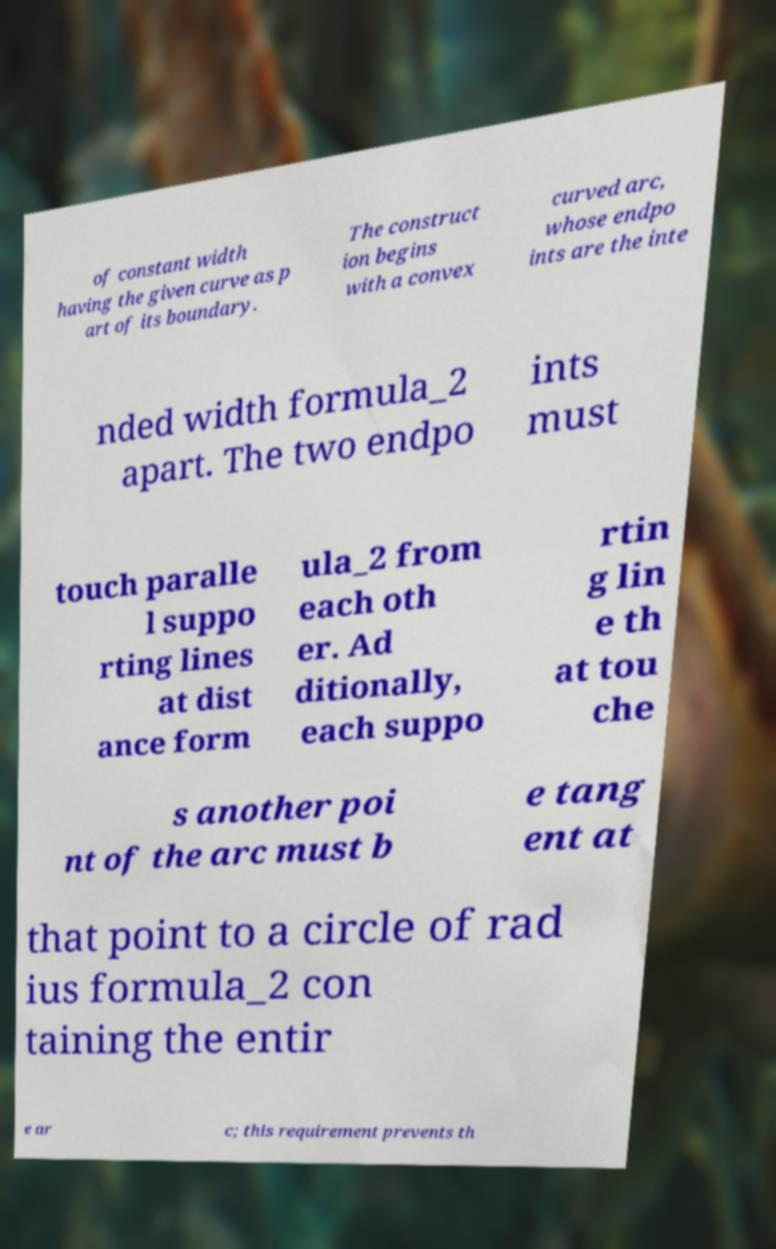I need the written content from this picture converted into text. Can you do that? of constant width having the given curve as p art of its boundary. The construct ion begins with a convex curved arc, whose endpo ints are the inte nded width formula_2 apart. The two endpo ints must touch paralle l suppo rting lines at dist ance form ula_2 from each oth er. Ad ditionally, each suppo rtin g lin e th at tou che s another poi nt of the arc must b e tang ent at that point to a circle of rad ius formula_2 con taining the entir e ar c; this requirement prevents th 